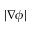<formula> <loc_0><loc_0><loc_500><loc_500>| \nabla \phi |</formula> 